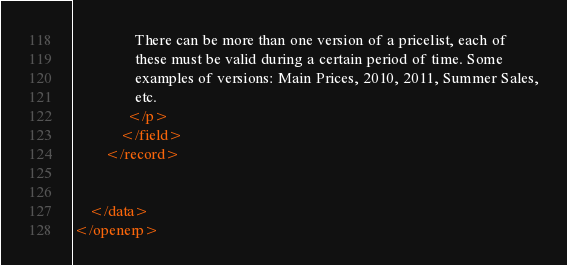Convert code to text. <code><loc_0><loc_0><loc_500><loc_500><_XML_>                There can be more than one version of a pricelist, each of
                these must be valid during a certain period of time. Some
                examples of versions: Main Prices, 2010, 2011, Summer Sales,
                etc.
              </p>
            </field>
        </record>
 

    </data>
</openerp></code> 